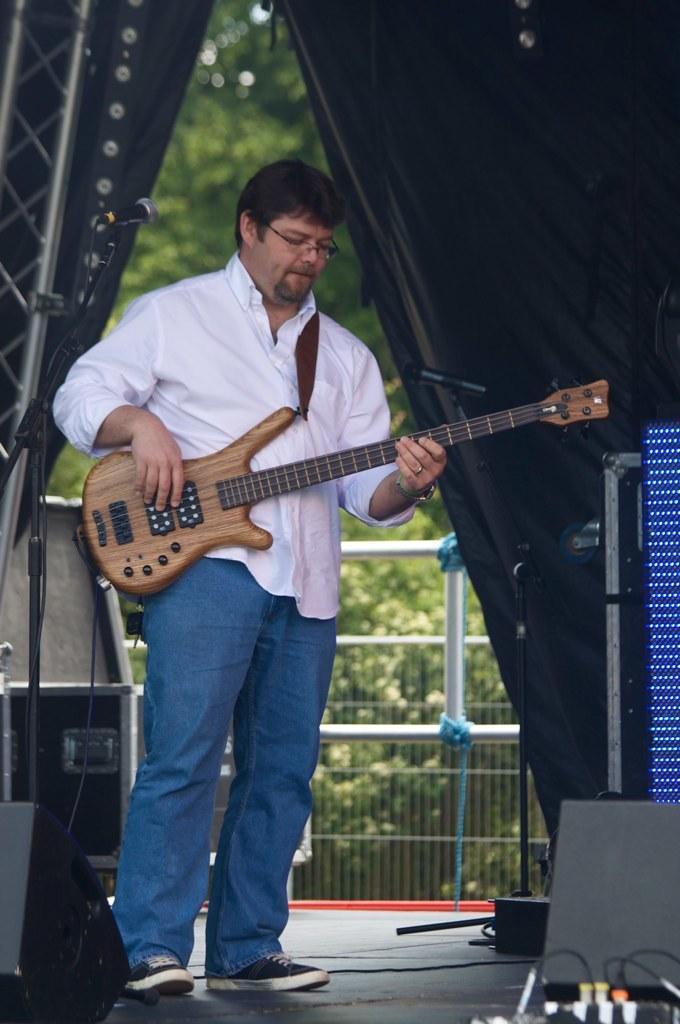Describe this image in one or two sentences. In this image there is a man standing. He is wearing white color shirt and blue jeans, and also playing a guitar. To the left there is mic stand and a mic. To the right there are black colored boxes. In the background there is a black cloth and many trees. 